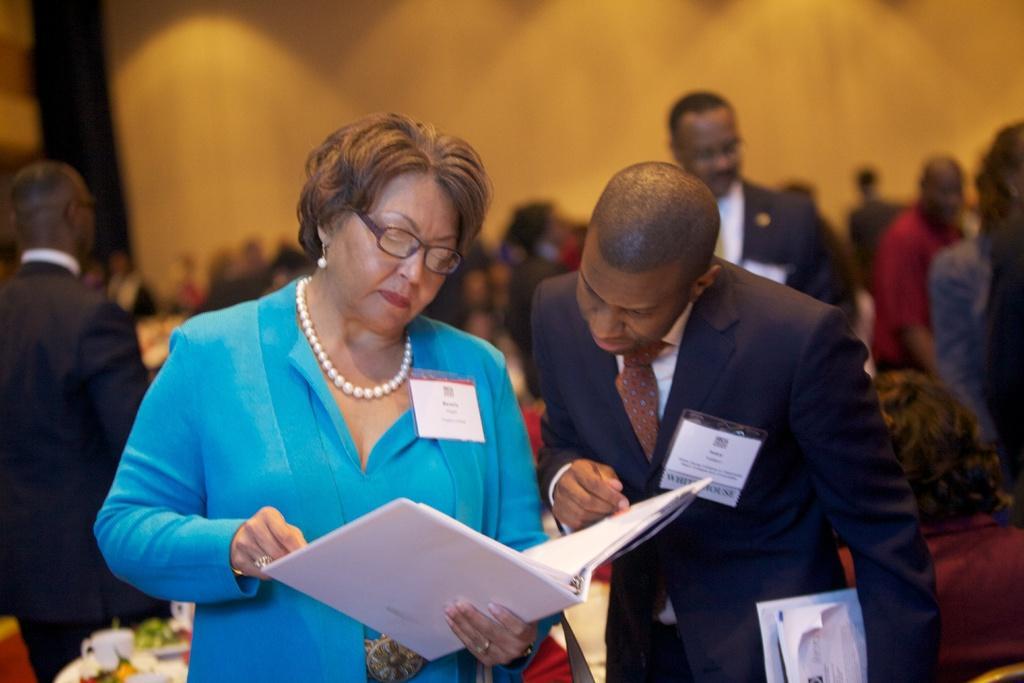Please provide a concise description of this image. Here in this picture in the front we can see a woman and a man standing on the floor over there and we can see the woman is holding a file in her hand and the person is also holding some papers and both of them are having ID cards on them and behind them also we can see number of people standing all over the place and we can see some tables and chairs also present over there. 